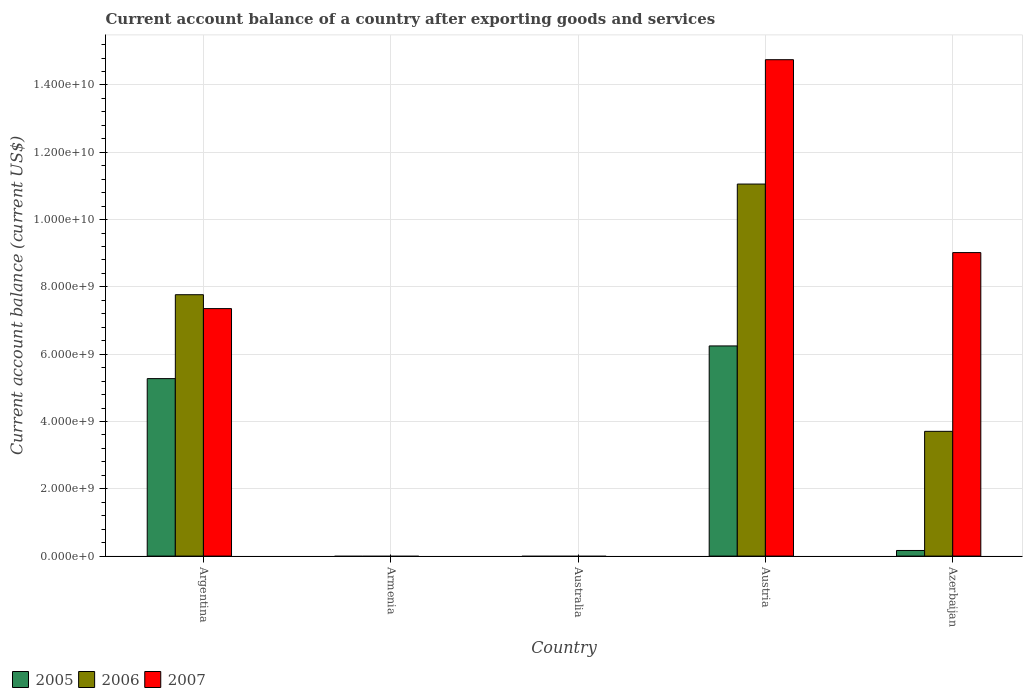Are the number of bars per tick equal to the number of legend labels?
Keep it short and to the point. No. How many bars are there on the 3rd tick from the left?
Your response must be concise. 0. How many bars are there on the 4th tick from the right?
Offer a very short reply. 0. What is the label of the 2nd group of bars from the left?
Give a very brief answer. Armenia. What is the account balance in 2007 in Armenia?
Your response must be concise. 0. Across all countries, what is the maximum account balance in 2006?
Give a very brief answer. 1.11e+1. Across all countries, what is the minimum account balance in 2006?
Give a very brief answer. 0. In which country was the account balance in 2006 maximum?
Your answer should be compact. Austria. What is the total account balance in 2005 in the graph?
Your response must be concise. 1.17e+1. What is the difference between the account balance in 2005 in Austria and that in Azerbaijan?
Offer a terse response. 6.08e+09. What is the difference between the account balance in 2007 in Austria and the account balance in 2006 in Argentina?
Offer a terse response. 6.98e+09. What is the average account balance in 2005 per country?
Your response must be concise. 2.34e+09. What is the difference between the account balance of/in 2007 and account balance of/in 2006 in Argentina?
Provide a succinct answer. -4.13e+08. In how many countries, is the account balance in 2007 greater than 13600000000 US$?
Make the answer very short. 1. What is the ratio of the account balance in 2005 in Austria to that in Azerbaijan?
Provide a short and direct response. 37.33. What is the difference between the highest and the second highest account balance in 2007?
Your response must be concise. -5.73e+09. What is the difference between the highest and the lowest account balance in 2006?
Offer a terse response. 1.11e+1. How many bars are there?
Offer a terse response. 9. Are the values on the major ticks of Y-axis written in scientific E-notation?
Your response must be concise. Yes. How many legend labels are there?
Your answer should be very brief. 3. What is the title of the graph?
Provide a succinct answer. Current account balance of a country after exporting goods and services. What is the label or title of the X-axis?
Provide a short and direct response. Country. What is the label or title of the Y-axis?
Offer a very short reply. Current account balance (current US$). What is the Current account balance (current US$) in 2005 in Argentina?
Keep it short and to the point. 5.27e+09. What is the Current account balance (current US$) of 2006 in Argentina?
Ensure brevity in your answer.  7.77e+09. What is the Current account balance (current US$) of 2007 in Argentina?
Your answer should be compact. 7.35e+09. What is the Current account balance (current US$) in 2005 in Armenia?
Ensure brevity in your answer.  0. What is the Current account balance (current US$) in 2006 in Armenia?
Ensure brevity in your answer.  0. What is the Current account balance (current US$) of 2005 in Australia?
Offer a terse response. 0. What is the Current account balance (current US$) in 2005 in Austria?
Give a very brief answer. 6.25e+09. What is the Current account balance (current US$) of 2006 in Austria?
Provide a short and direct response. 1.11e+1. What is the Current account balance (current US$) in 2007 in Austria?
Provide a short and direct response. 1.48e+1. What is the Current account balance (current US$) in 2005 in Azerbaijan?
Give a very brief answer. 1.67e+08. What is the Current account balance (current US$) in 2006 in Azerbaijan?
Make the answer very short. 3.71e+09. What is the Current account balance (current US$) of 2007 in Azerbaijan?
Make the answer very short. 9.02e+09. Across all countries, what is the maximum Current account balance (current US$) of 2005?
Keep it short and to the point. 6.25e+09. Across all countries, what is the maximum Current account balance (current US$) of 2006?
Keep it short and to the point. 1.11e+1. Across all countries, what is the maximum Current account balance (current US$) in 2007?
Your response must be concise. 1.48e+1. Across all countries, what is the minimum Current account balance (current US$) in 2006?
Your response must be concise. 0. What is the total Current account balance (current US$) in 2005 in the graph?
Keep it short and to the point. 1.17e+1. What is the total Current account balance (current US$) in 2006 in the graph?
Offer a terse response. 2.25e+1. What is the total Current account balance (current US$) in 2007 in the graph?
Give a very brief answer. 3.11e+1. What is the difference between the Current account balance (current US$) in 2005 in Argentina and that in Austria?
Provide a short and direct response. -9.71e+08. What is the difference between the Current account balance (current US$) in 2006 in Argentina and that in Austria?
Your response must be concise. -3.29e+09. What is the difference between the Current account balance (current US$) of 2007 in Argentina and that in Austria?
Make the answer very short. -7.40e+09. What is the difference between the Current account balance (current US$) in 2005 in Argentina and that in Azerbaijan?
Give a very brief answer. 5.11e+09. What is the difference between the Current account balance (current US$) of 2006 in Argentina and that in Azerbaijan?
Your response must be concise. 4.06e+09. What is the difference between the Current account balance (current US$) in 2007 in Argentina and that in Azerbaijan?
Your answer should be compact. -1.66e+09. What is the difference between the Current account balance (current US$) of 2005 in Austria and that in Azerbaijan?
Your answer should be compact. 6.08e+09. What is the difference between the Current account balance (current US$) of 2006 in Austria and that in Azerbaijan?
Keep it short and to the point. 7.35e+09. What is the difference between the Current account balance (current US$) of 2007 in Austria and that in Azerbaijan?
Make the answer very short. 5.73e+09. What is the difference between the Current account balance (current US$) of 2005 in Argentina and the Current account balance (current US$) of 2006 in Austria?
Your answer should be very brief. -5.78e+09. What is the difference between the Current account balance (current US$) of 2005 in Argentina and the Current account balance (current US$) of 2007 in Austria?
Offer a very short reply. -9.48e+09. What is the difference between the Current account balance (current US$) in 2006 in Argentina and the Current account balance (current US$) in 2007 in Austria?
Keep it short and to the point. -6.98e+09. What is the difference between the Current account balance (current US$) of 2005 in Argentina and the Current account balance (current US$) of 2006 in Azerbaijan?
Offer a terse response. 1.57e+09. What is the difference between the Current account balance (current US$) in 2005 in Argentina and the Current account balance (current US$) in 2007 in Azerbaijan?
Keep it short and to the point. -3.75e+09. What is the difference between the Current account balance (current US$) of 2006 in Argentina and the Current account balance (current US$) of 2007 in Azerbaijan?
Your answer should be very brief. -1.25e+09. What is the difference between the Current account balance (current US$) in 2005 in Austria and the Current account balance (current US$) in 2006 in Azerbaijan?
Offer a very short reply. 2.54e+09. What is the difference between the Current account balance (current US$) of 2005 in Austria and the Current account balance (current US$) of 2007 in Azerbaijan?
Give a very brief answer. -2.77e+09. What is the difference between the Current account balance (current US$) of 2006 in Austria and the Current account balance (current US$) of 2007 in Azerbaijan?
Provide a short and direct response. 2.04e+09. What is the average Current account balance (current US$) in 2005 per country?
Ensure brevity in your answer.  2.34e+09. What is the average Current account balance (current US$) in 2006 per country?
Offer a very short reply. 4.51e+09. What is the average Current account balance (current US$) in 2007 per country?
Make the answer very short. 6.22e+09. What is the difference between the Current account balance (current US$) of 2005 and Current account balance (current US$) of 2006 in Argentina?
Give a very brief answer. -2.49e+09. What is the difference between the Current account balance (current US$) in 2005 and Current account balance (current US$) in 2007 in Argentina?
Offer a very short reply. -2.08e+09. What is the difference between the Current account balance (current US$) of 2006 and Current account balance (current US$) of 2007 in Argentina?
Ensure brevity in your answer.  4.13e+08. What is the difference between the Current account balance (current US$) of 2005 and Current account balance (current US$) of 2006 in Austria?
Your answer should be very brief. -4.81e+09. What is the difference between the Current account balance (current US$) of 2005 and Current account balance (current US$) of 2007 in Austria?
Keep it short and to the point. -8.51e+09. What is the difference between the Current account balance (current US$) in 2006 and Current account balance (current US$) in 2007 in Austria?
Your answer should be compact. -3.70e+09. What is the difference between the Current account balance (current US$) in 2005 and Current account balance (current US$) in 2006 in Azerbaijan?
Ensure brevity in your answer.  -3.54e+09. What is the difference between the Current account balance (current US$) in 2005 and Current account balance (current US$) in 2007 in Azerbaijan?
Keep it short and to the point. -8.85e+09. What is the difference between the Current account balance (current US$) of 2006 and Current account balance (current US$) of 2007 in Azerbaijan?
Give a very brief answer. -5.31e+09. What is the ratio of the Current account balance (current US$) of 2005 in Argentina to that in Austria?
Your answer should be very brief. 0.84. What is the ratio of the Current account balance (current US$) in 2006 in Argentina to that in Austria?
Provide a short and direct response. 0.7. What is the ratio of the Current account balance (current US$) of 2007 in Argentina to that in Austria?
Your answer should be compact. 0.5. What is the ratio of the Current account balance (current US$) of 2005 in Argentina to that in Azerbaijan?
Provide a succinct answer. 31.52. What is the ratio of the Current account balance (current US$) of 2006 in Argentina to that in Azerbaijan?
Ensure brevity in your answer.  2.09. What is the ratio of the Current account balance (current US$) in 2007 in Argentina to that in Azerbaijan?
Provide a succinct answer. 0.82. What is the ratio of the Current account balance (current US$) in 2005 in Austria to that in Azerbaijan?
Give a very brief answer. 37.33. What is the ratio of the Current account balance (current US$) of 2006 in Austria to that in Azerbaijan?
Make the answer very short. 2.98. What is the ratio of the Current account balance (current US$) of 2007 in Austria to that in Azerbaijan?
Give a very brief answer. 1.64. What is the difference between the highest and the second highest Current account balance (current US$) in 2005?
Ensure brevity in your answer.  9.71e+08. What is the difference between the highest and the second highest Current account balance (current US$) in 2006?
Provide a short and direct response. 3.29e+09. What is the difference between the highest and the second highest Current account balance (current US$) in 2007?
Provide a short and direct response. 5.73e+09. What is the difference between the highest and the lowest Current account balance (current US$) in 2005?
Ensure brevity in your answer.  6.25e+09. What is the difference between the highest and the lowest Current account balance (current US$) in 2006?
Ensure brevity in your answer.  1.11e+1. What is the difference between the highest and the lowest Current account balance (current US$) in 2007?
Your answer should be very brief. 1.48e+1. 